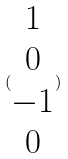<formula> <loc_0><loc_0><loc_500><loc_500>( \begin{matrix} 1 \\ 0 \\ - 1 \\ 0 \end{matrix} )</formula> 